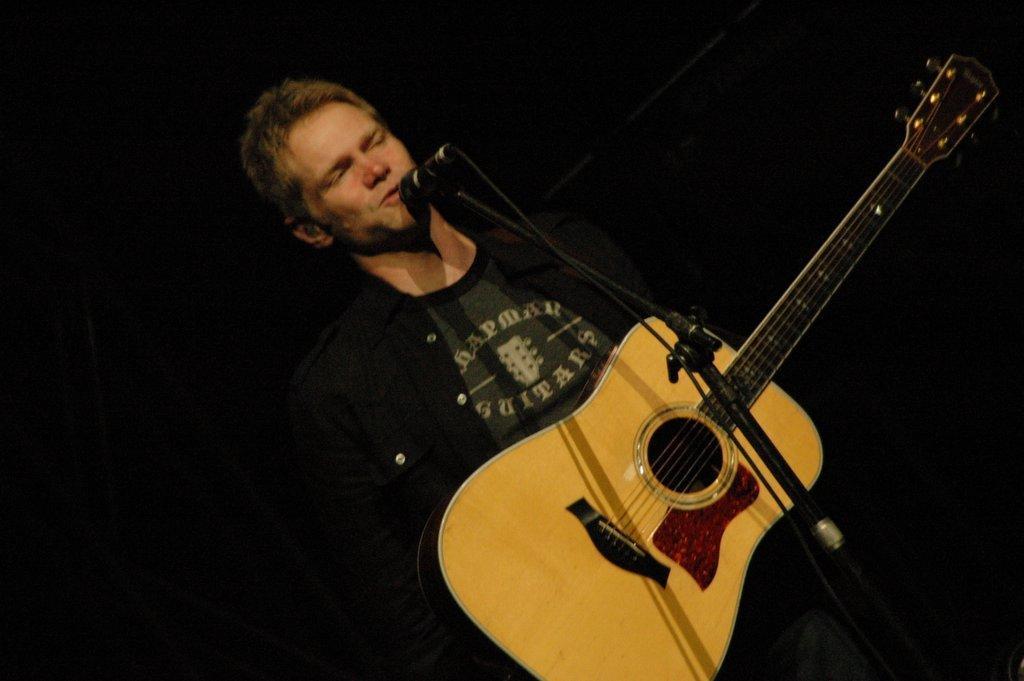Could you give a brief overview of what you see in this image? There is a man who is standing with a guitar in his hand and a mic near his mouth and a man is singing and playing the guitar. 